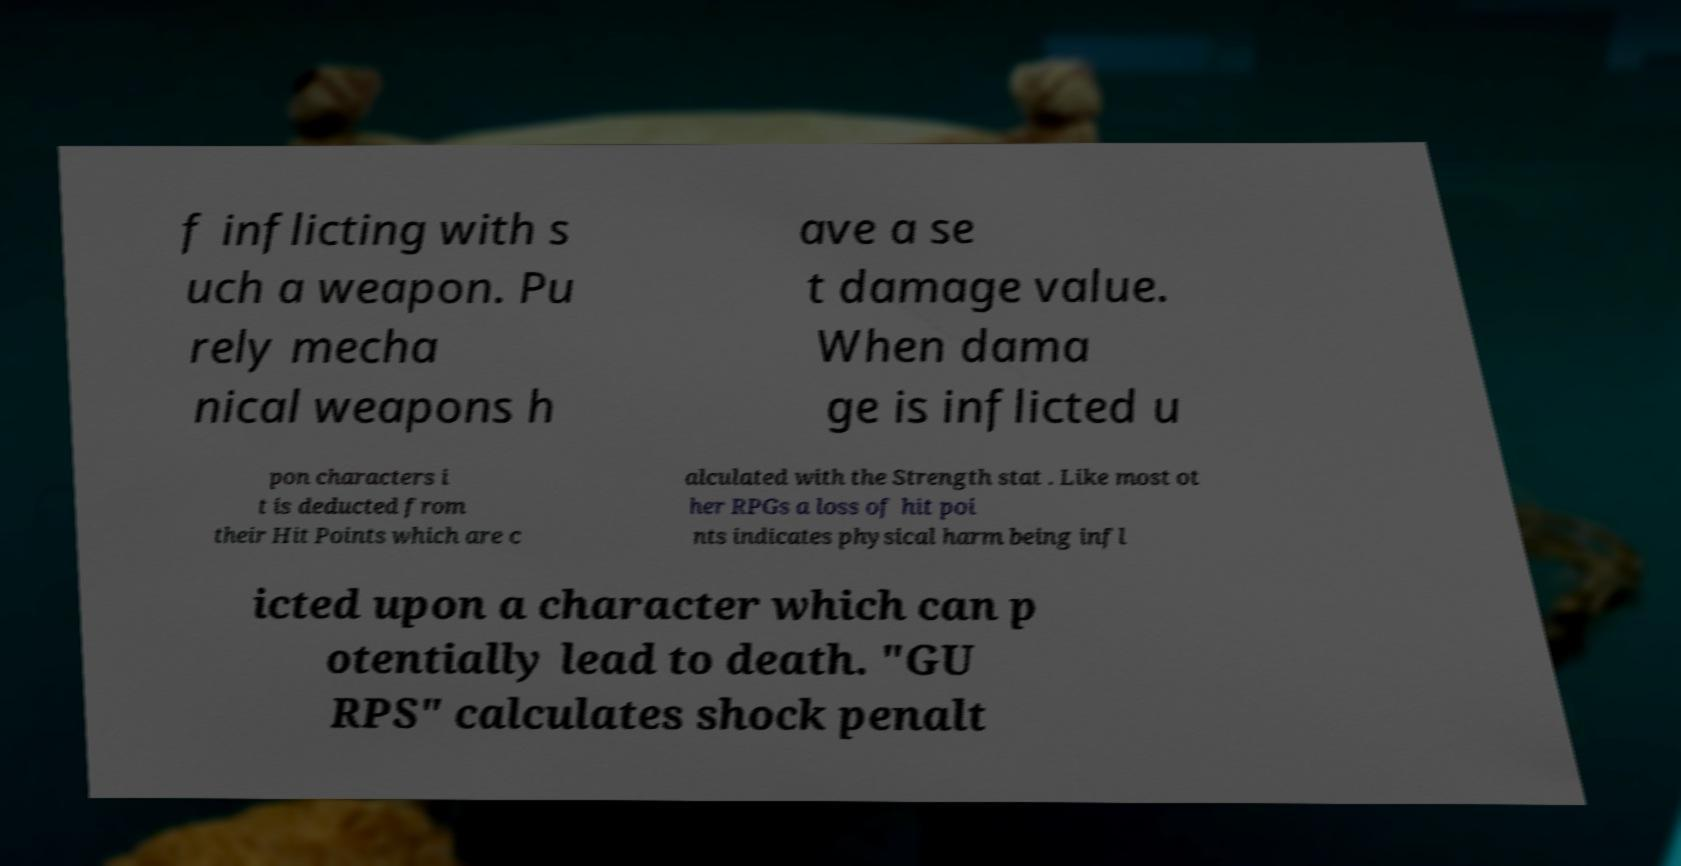For documentation purposes, I need the text within this image transcribed. Could you provide that? f inflicting with s uch a weapon. Pu rely mecha nical weapons h ave a se t damage value. When dama ge is inflicted u pon characters i t is deducted from their Hit Points which are c alculated with the Strength stat . Like most ot her RPGs a loss of hit poi nts indicates physical harm being infl icted upon a character which can p otentially lead to death. "GU RPS" calculates shock penalt 